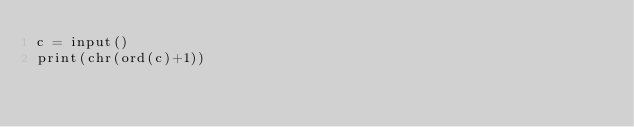Convert code to text. <code><loc_0><loc_0><loc_500><loc_500><_Python_>c = input()
print(chr(ord(c)+1))</code> 